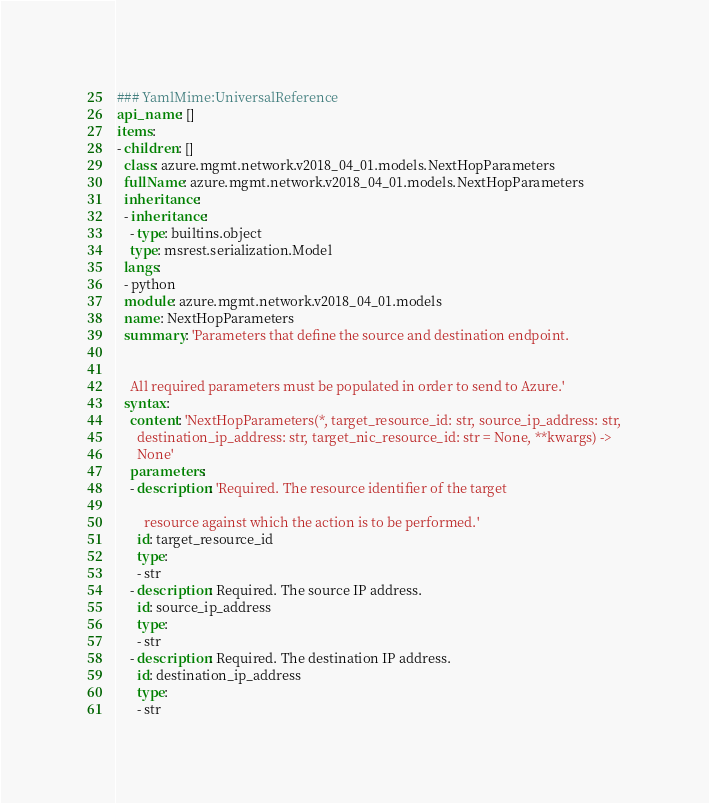Convert code to text. <code><loc_0><loc_0><loc_500><loc_500><_YAML_>### YamlMime:UniversalReference
api_name: []
items:
- children: []
  class: azure.mgmt.network.v2018_04_01.models.NextHopParameters
  fullName: azure.mgmt.network.v2018_04_01.models.NextHopParameters
  inheritance:
  - inheritance:
    - type: builtins.object
    type: msrest.serialization.Model
  langs:
  - python
  module: azure.mgmt.network.v2018_04_01.models
  name: NextHopParameters
  summary: 'Parameters that define the source and destination endpoint.


    All required parameters must be populated in order to send to Azure.'
  syntax:
    content: 'NextHopParameters(*, target_resource_id: str, source_ip_address: str,
      destination_ip_address: str, target_nic_resource_id: str = None, **kwargs) ->
      None'
    parameters:
    - description: 'Required. The resource identifier of the target

        resource against which the action is to be performed.'
      id: target_resource_id
      type:
      - str
    - description: Required. The source IP address.
      id: source_ip_address
      type:
      - str
    - description: Required. The destination IP address.
      id: destination_ip_address
      type:
      - str</code> 